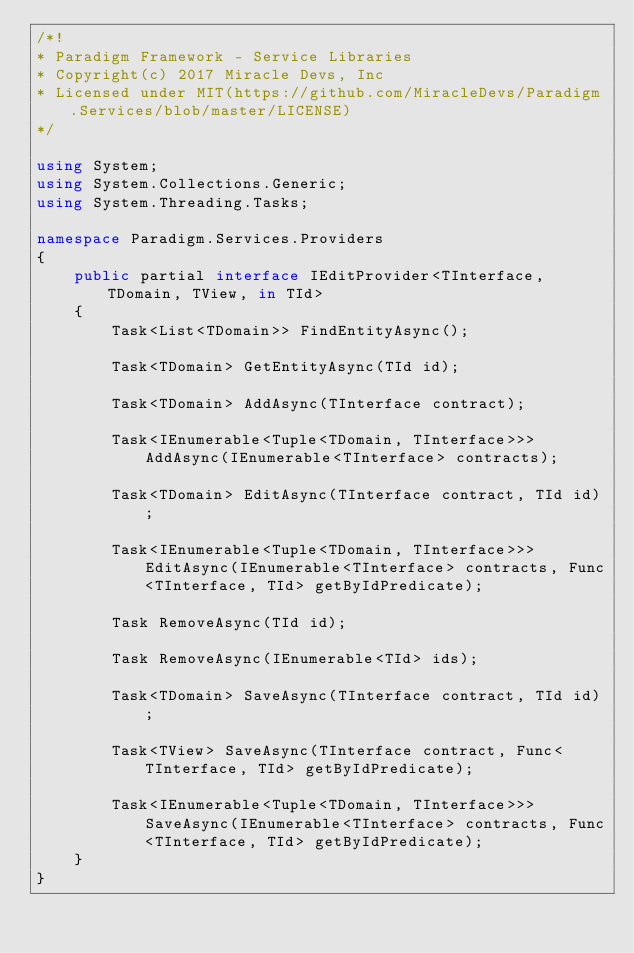<code> <loc_0><loc_0><loc_500><loc_500><_C#_>/*!
* Paradigm Framework - Service Libraries
* Copyright(c) 2017 Miracle Devs, Inc
* Licensed under MIT(https://github.com/MiracleDevs/Paradigm.Services/blob/master/LICENSE)
*/

using System;
using System.Collections.Generic;
using System.Threading.Tasks;

namespace Paradigm.Services.Providers
{
    public partial interface IEditProvider<TInterface, TDomain, TView, in TId>
    {
        Task<List<TDomain>> FindEntityAsync();

        Task<TDomain> GetEntityAsync(TId id);

        Task<TDomain> AddAsync(TInterface contract);

        Task<IEnumerable<Tuple<TDomain, TInterface>>> AddAsync(IEnumerable<TInterface> contracts);

        Task<TDomain> EditAsync(TInterface contract, TId id);

        Task<IEnumerable<Tuple<TDomain, TInterface>>> EditAsync(IEnumerable<TInterface> contracts, Func<TInterface, TId> getByIdPredicate);

        Task RemoveAsync(TId id);

        Task RemoveAsync(IEnumerable<TId> ids);

        Task<TDomain> SaveAsync(TInterface contract, TId id);

        Task<TView> SaveAsync(TInterface contract, Func<TInterface, TId> getByIdPredicate);

        Task<IEnumerable<Tuple<TDomain, TInterface>>> SaveAsync(IEnumerable<TInterface> contracts, Func<TInterface, TId> getByIdPredicate);
    }
}</code> 